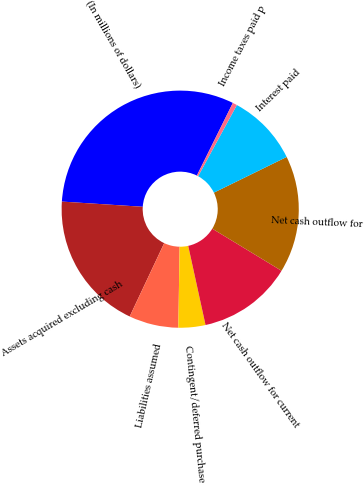Convert chart. <chart><loc_0><loc_0><loc_500><loc_500><pie_chart><fcel>(In millions of dollars)<fcel>Assets acquired excluding cash<fcel>Liabilities assumed<fcel>Contingent/deferred purchase<fcel>Net cash outflow for current<fcel>Net cash outflow for<fcel>Interest paid<fcel>Income taxes paid p<nl><fcel>31.3%<fcel>19.02%<fcel>6.75%<fcel>3.68%<fcel>12.88%<fcel>15.95%<fcel>9.81%<fcel>0.61%<nl></chart> 